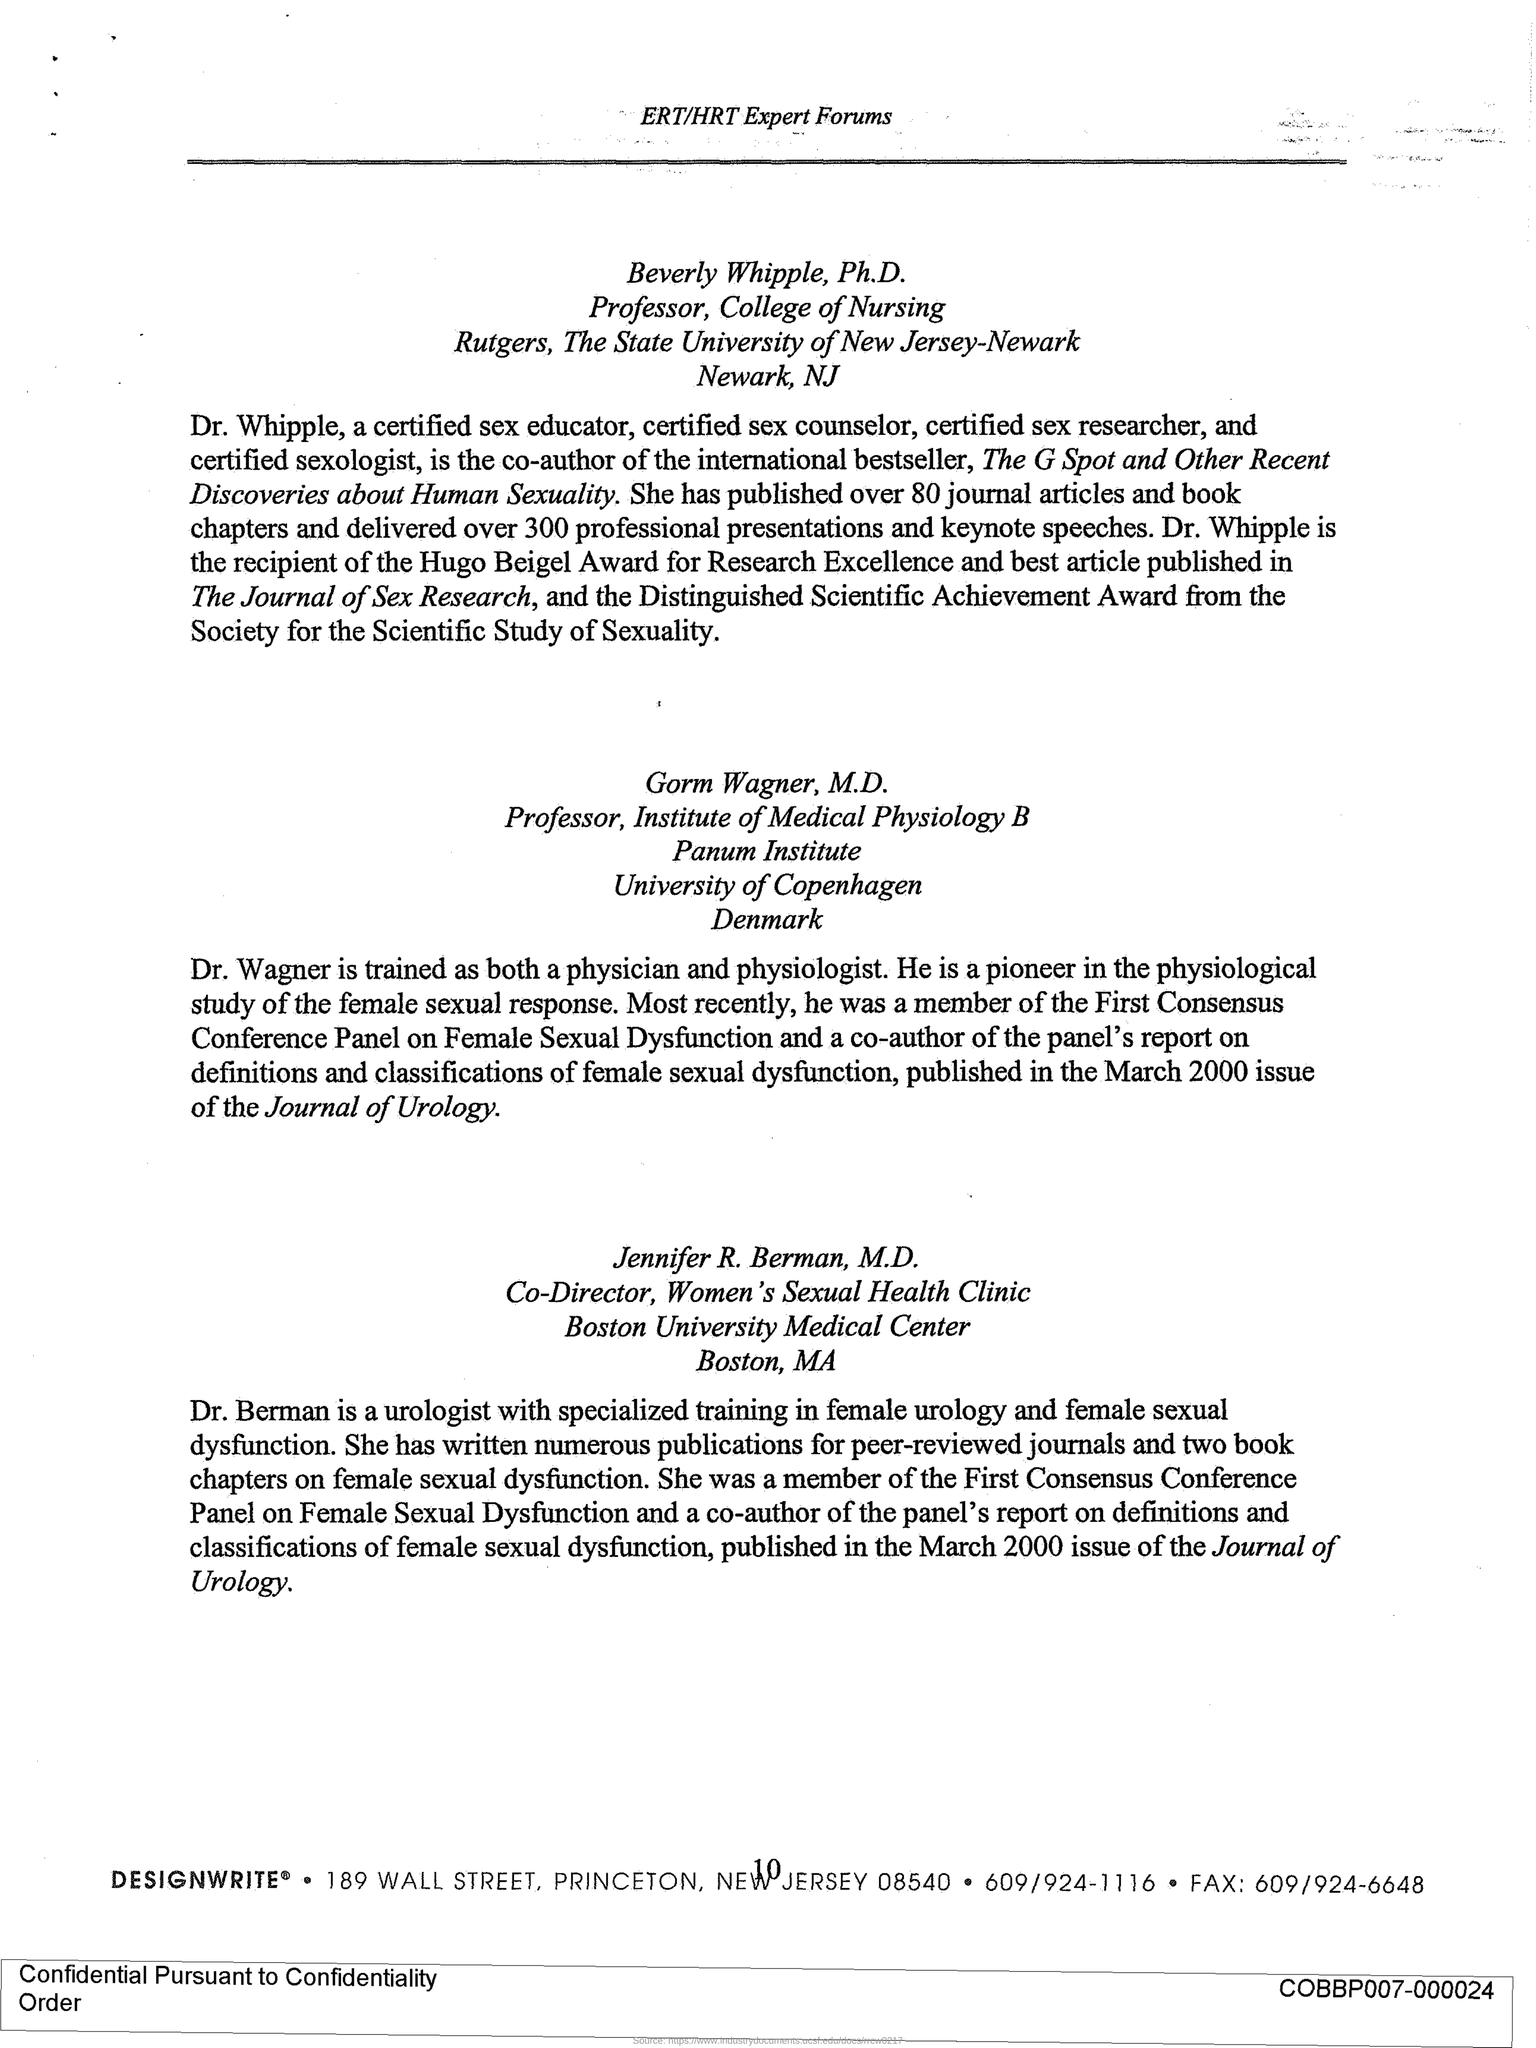Give some essential details in this illustration. The G spot was co-authored by Dr. Whipple. Dr. Wagner, a physician and physiologist, has been trained to excel in both fields. 